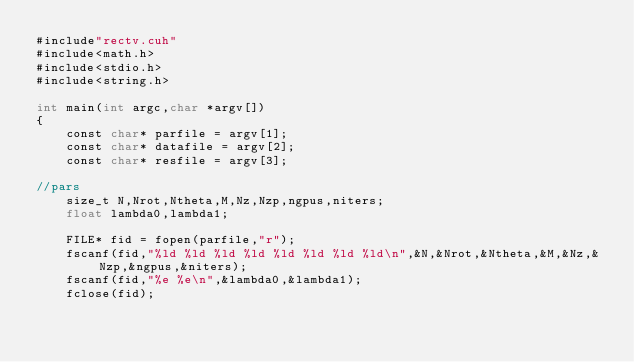Convert code to text. <code><loc_0><loc_0><loc_500><loc_500><_Cuda_>#include"rectv.cuh"
#include<math.h>
#include<stdio.h>
#include<string.h>

int main(int argc,char *argv[])
{
	const char* parfile = argv[1];
	const char* datafile = argv[2];
	const char* resfile = argv[3];

//pars
	size_t N,Nrot,Ntheta,M,Nz,Nzp,ngpus,niters;
	float lambda0,lambda1;

	FILE* fid = fopen(parfile,"r");
	fscanf(fid,"%ld %ld %ld %ld %ld %ld %ld %ld\n",&N,&Nrot,&Ntheta,&M,&Nz,&Nzp,&ngpus,&niters);
	fscanf(fid,"%e %e\n",&lambda0,&lambda1);
	fclose(fid);
</code> 